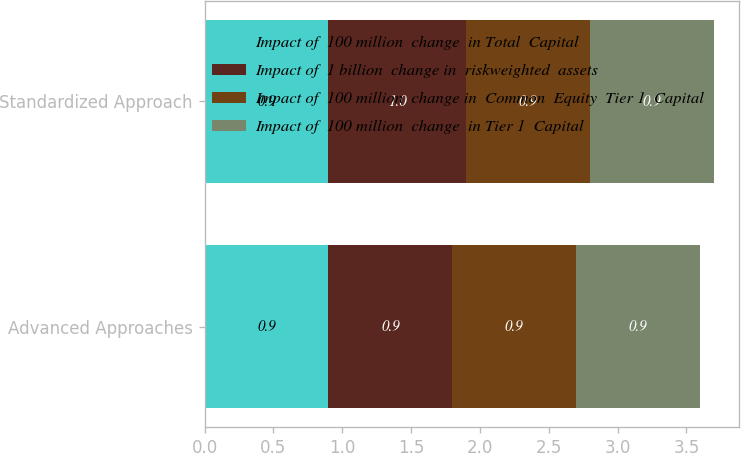<chart> <loc_0><loc_0><loc_500><loc_500><stacked_bar_chart><ecel><fcel>Advanced Approaches<fcel>Standardized Approach<nl><fcel>Impact of  100 million  change  in Total  Capital<fcel>0.9<fcel>0.9<nl><fcel>Impact of  1 billion  change in  riskweighted  assets<fcel>0.9<fcel>1<nl><fcel>Impact of  100 million  change in  Common  Equity  Tier 1  Capital<fcel>0.9<fcel>0.9<nl><fcel>Impact of  100 million  change  in Tier 1  Capital<fcel>0.9<fcel>0.9<nl></chart> 